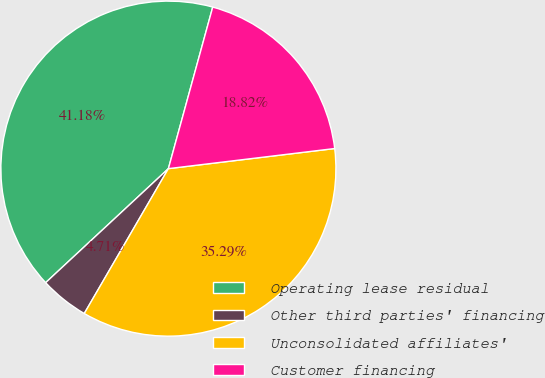<chart> <loc_0><loc_0><loc_500><loc_500><pie_chart><fcel>Operating lease residual<fcel>Other third parties' financing<fcel>Unconsolidated affiliates'<fcel>Customer financing<nl><fcel>41.18%<fcel>4.71%<fcel>35.29%<fcel>18.82%<nl></chart> 